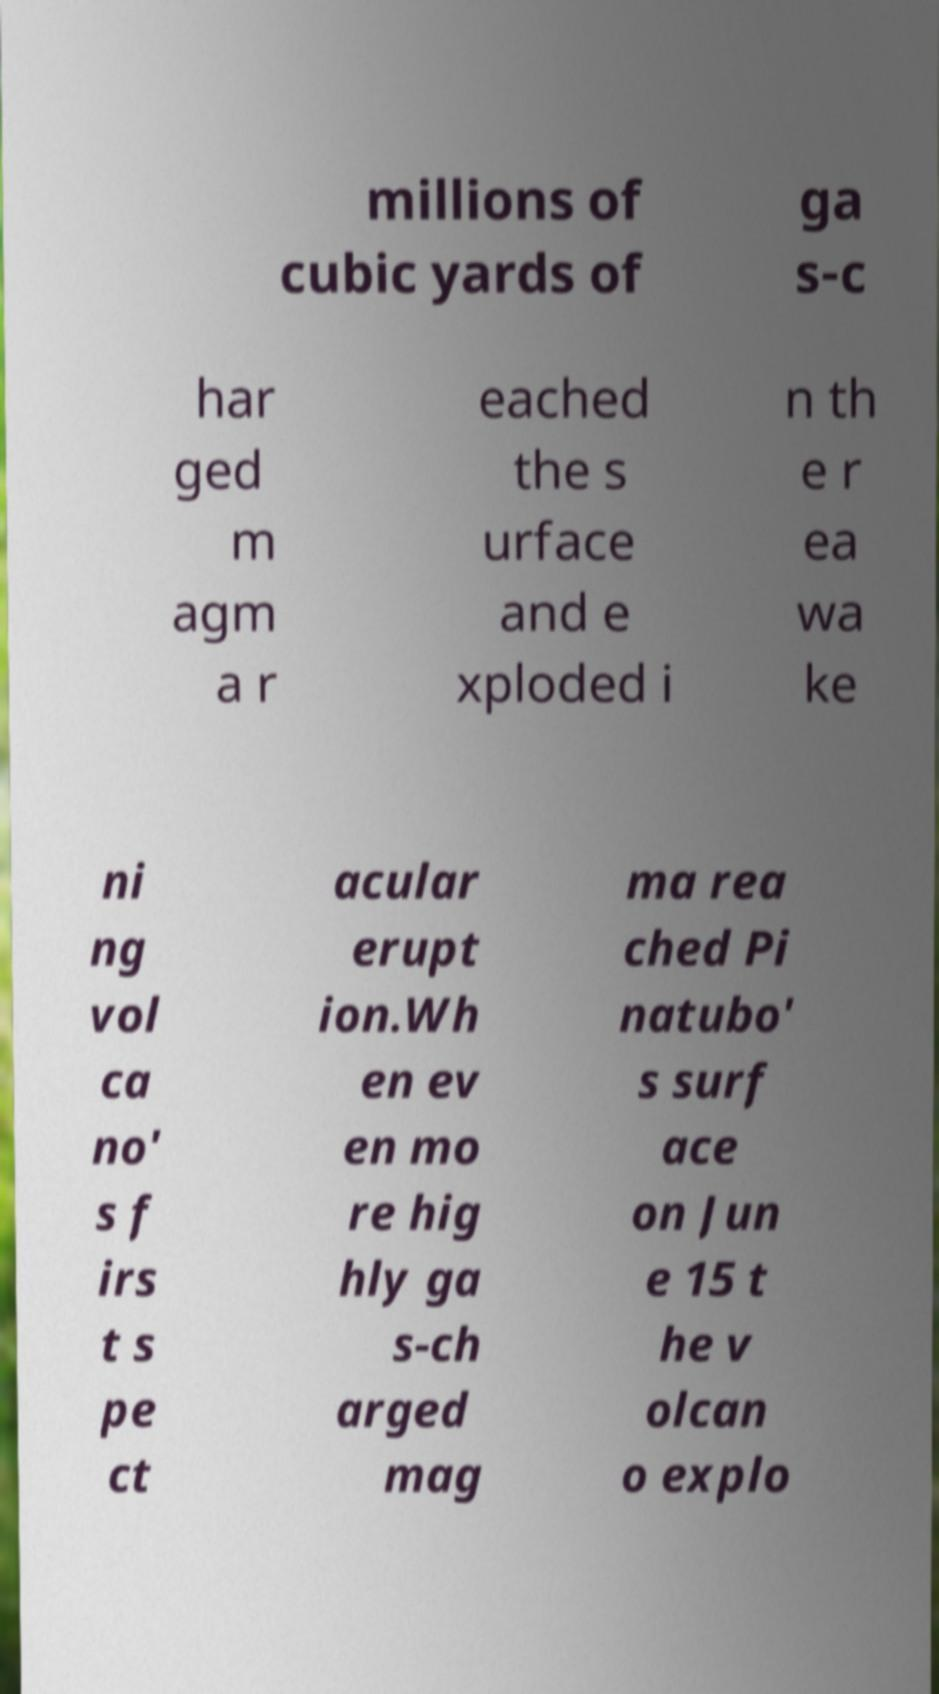What messages or text are displayed in this image? I need them in a readable, typed format. millions of cubic yards of ga s-c har ged m agm a r eached the s urface and e xploded i n th e r ea wa ke ni ng vol ca no' s f irs t s pe ct acular erupt ion.Wh en ev en mo re hig hly ga s-ch arged mag ma rea ched Pi natubo' s surf ace on Jun e 15 t he v olcan o explo 